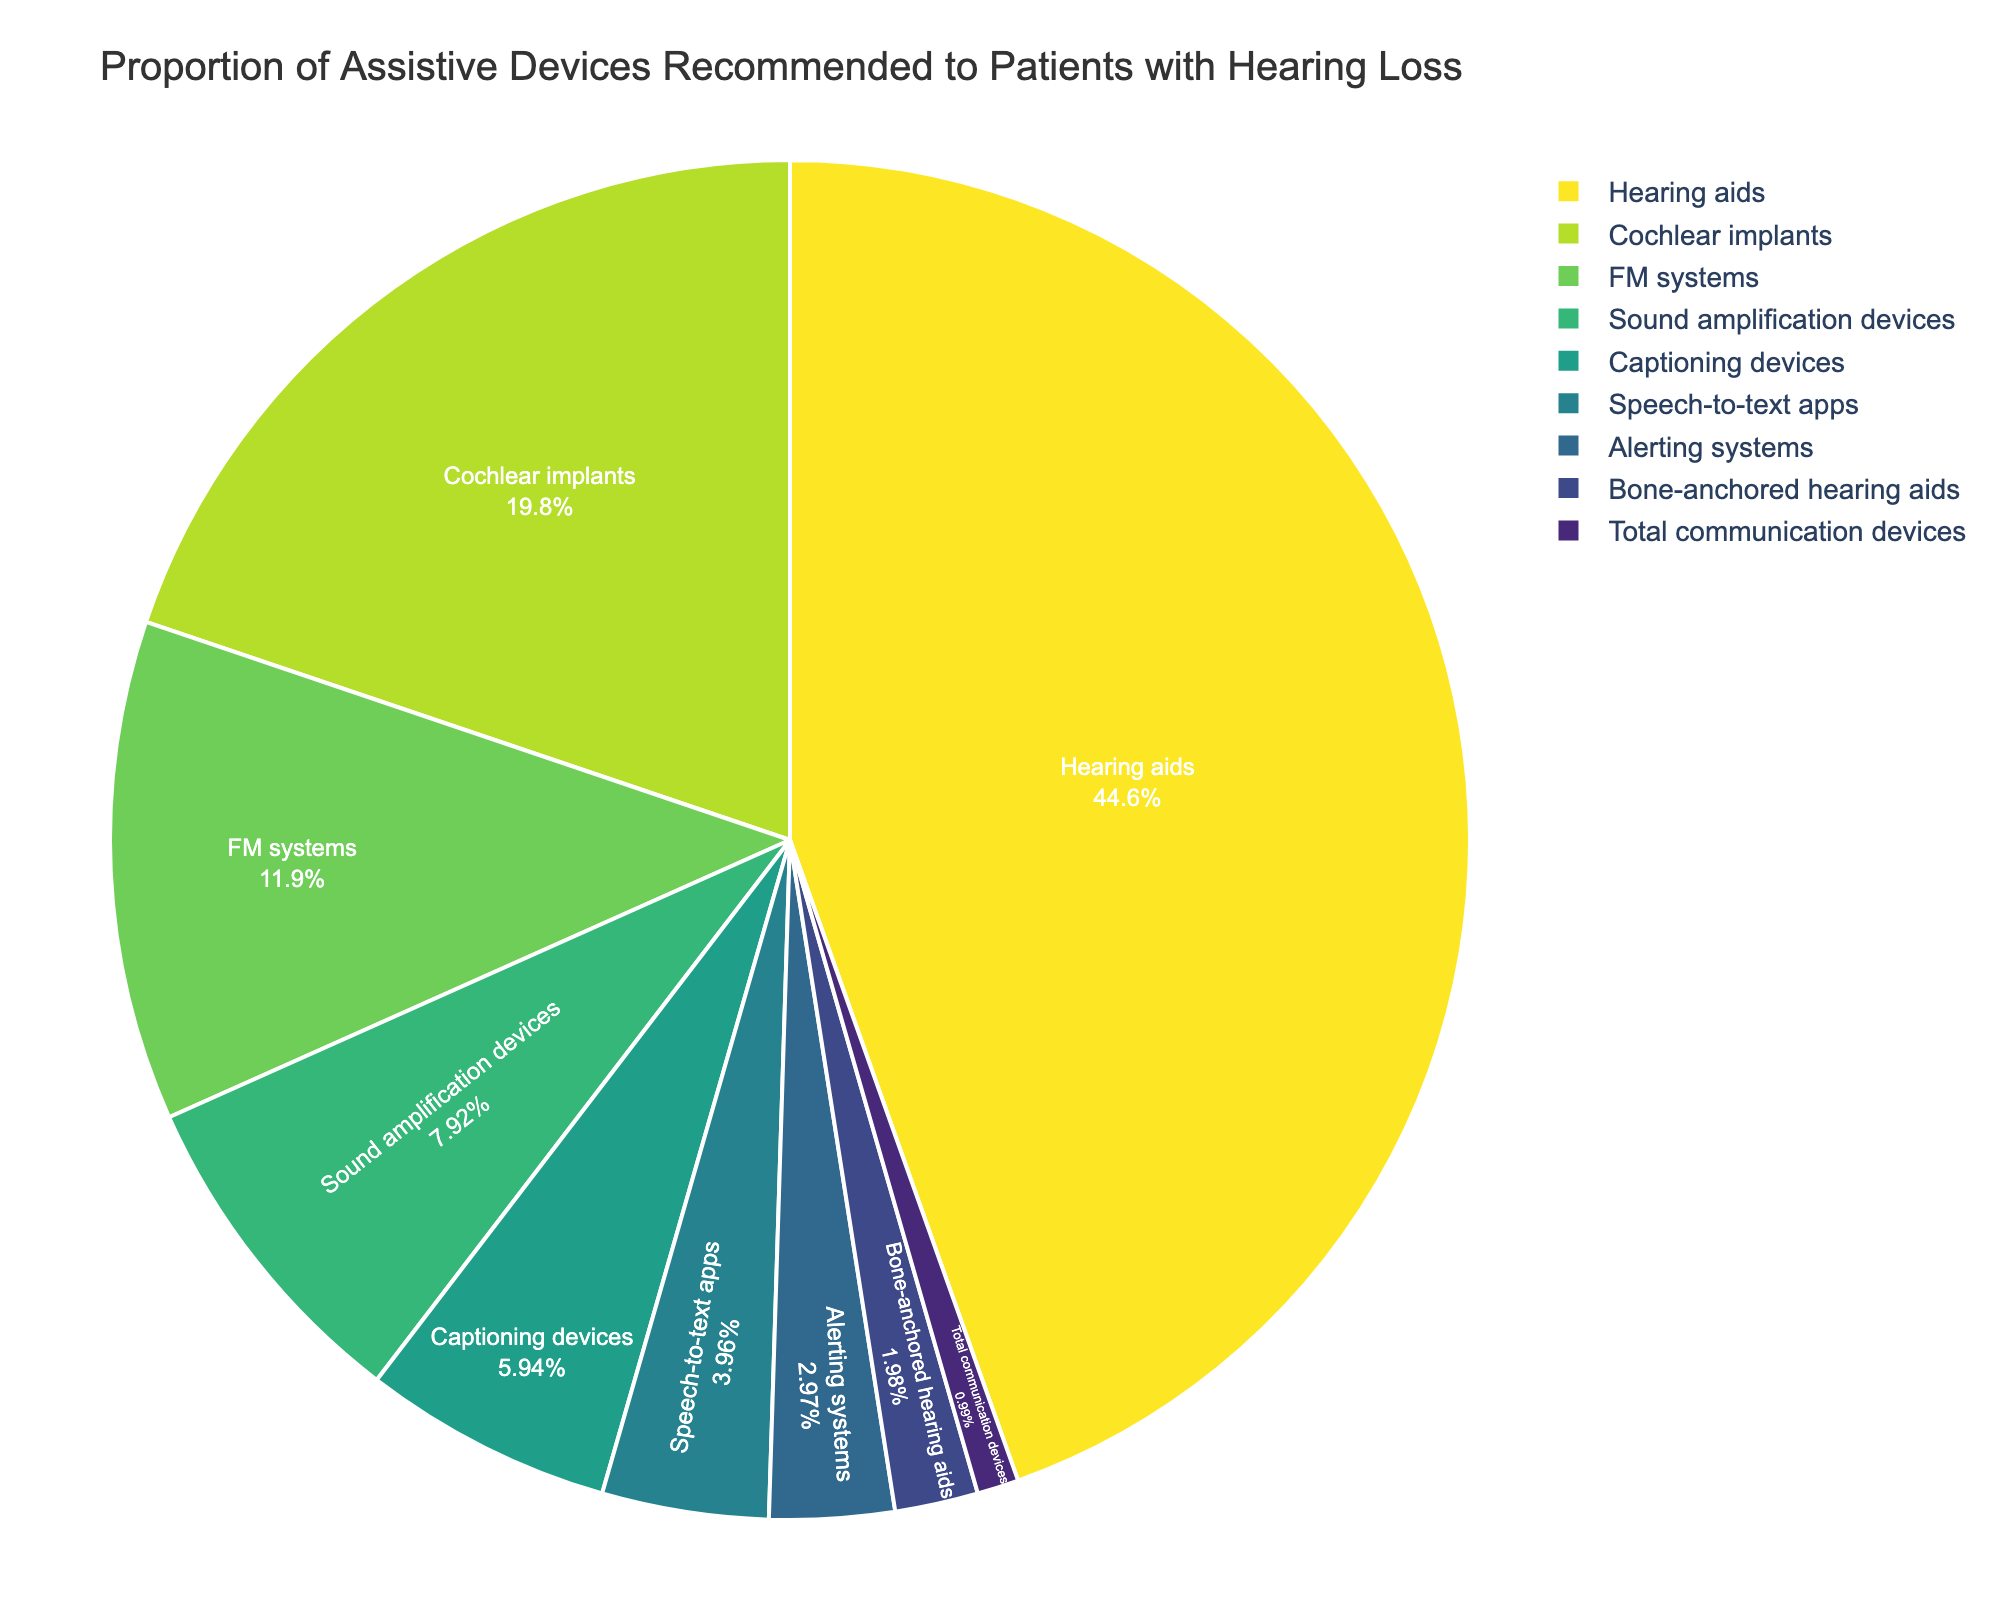what is the most recommended assistive device? The pie chart shows the proportion of different assistive devices recommended to patients with hearing loss. By looking at the chart, we can see that the device with the largest portion is Hearing aids, which accounts for 45%.
Answer: Hearing aids Which assistive device is recommended the least? According to the pie chart, the device with the smallest portion is the Total communication devices, which accounts for 1%.
Answer: Total communication devices What is the combined percentage of FM systems, Sound amplification devices, and Captioning devices? From the pie chart, FM systems account for 12%, Sound amplification devices for 8%, and Captioning devices for 6%. Adding these together: 12% + 8% + 6% = 26%.
Answer: 26% How much greater is the recommendation percentage for Hearing aids compared to Bone-anchored hearing aids? Hearing aids account for 45% and Bone-anchored hearing aids account for 2%. By subtracting the smaller value from the larger one: 45% - 2% = 43%.
Answer: 43% Which two devices combined provide more than one-third of the recommendations? We look for the devices that together exceed 33.33%. Hearing aids account for 45%, and that alone already exceeds one-third, so adding any other device would also exceed one-third.
Answer: Hearing aids and any other device Of the assistive devices that have a percentage less than 10%, which one has the highest percentage? The devices with a percentage less than 10% are Sound amplification devices (8%), Captioning devices (6%), Speech-to-text apps (4%), Alerting systems (3%), Bone-anchored hearing aids (2%), and Total communication devices (1%). The highest among these is Sound amplification devices at 8%.
Answer: Sound amplification devices What percentage of recommendations go to devices that are not Hearing aids or Cochlear implants? First, find the percentage for Hearing aids (45%) and Cochlear implants (20%). Adding them gives: 45% + 20% = 65%. The rest of the devices account for 100% - 65% = 35%.
Answer: 35% Are FM systems recommended more frequently than Cochlear implants? By checking the percentages, FM systems are 12% whereas Cochlear implants are 20%. Therefore, FM systems are recommended less frequently than Cochlear implants.
Answer: No How does the recommendation percentage for Cochlear implants compare to Captioning devices? Cochlear implants account for 20%, and Captioning devices account for 6%. Comparing these values, Cochlear implants are recommended more frequently than Captioning devices by 20% - 6% = 14%.
Answer: Cochlear implants are recommended 14% more Which devices have recommendation percentages closest to each other? By examining the chart, the percentages close to each other are: Sound amplification devices (8%), Captioning devices (6%), and Speech-to-text apps (4%). The closest pair would be Sound amplification devices and Captioning devices with a 2% difference.
Answer: Sound amplification devices and Captioning devices 